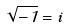<formula> <loc_0><loc_0><loc_500><loc_500>\sqrt { - 1 } = i</formula> 